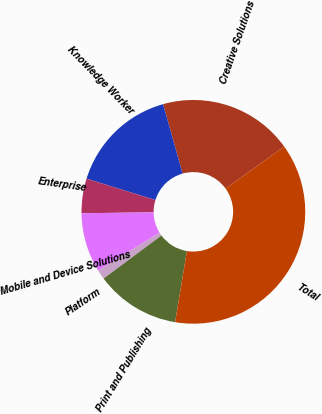Convert chart. <chart><loc_0><loc_0><loc_500><loc_500><pie_chart><fcel>Creative Solutions<fcel>Knowledge Worker<fcel>Enterprise<fcel>Mobile and Device Solutions<fcel>Platform<fcel>Print and Publishing<fcel>Total<nl><fcel>19.45%<fcel>15.84%<fcel>4.99%<fcel>8.6%<fcel>1.37%<fcel>12.22%<fcel>37.53%<nl></chart> 